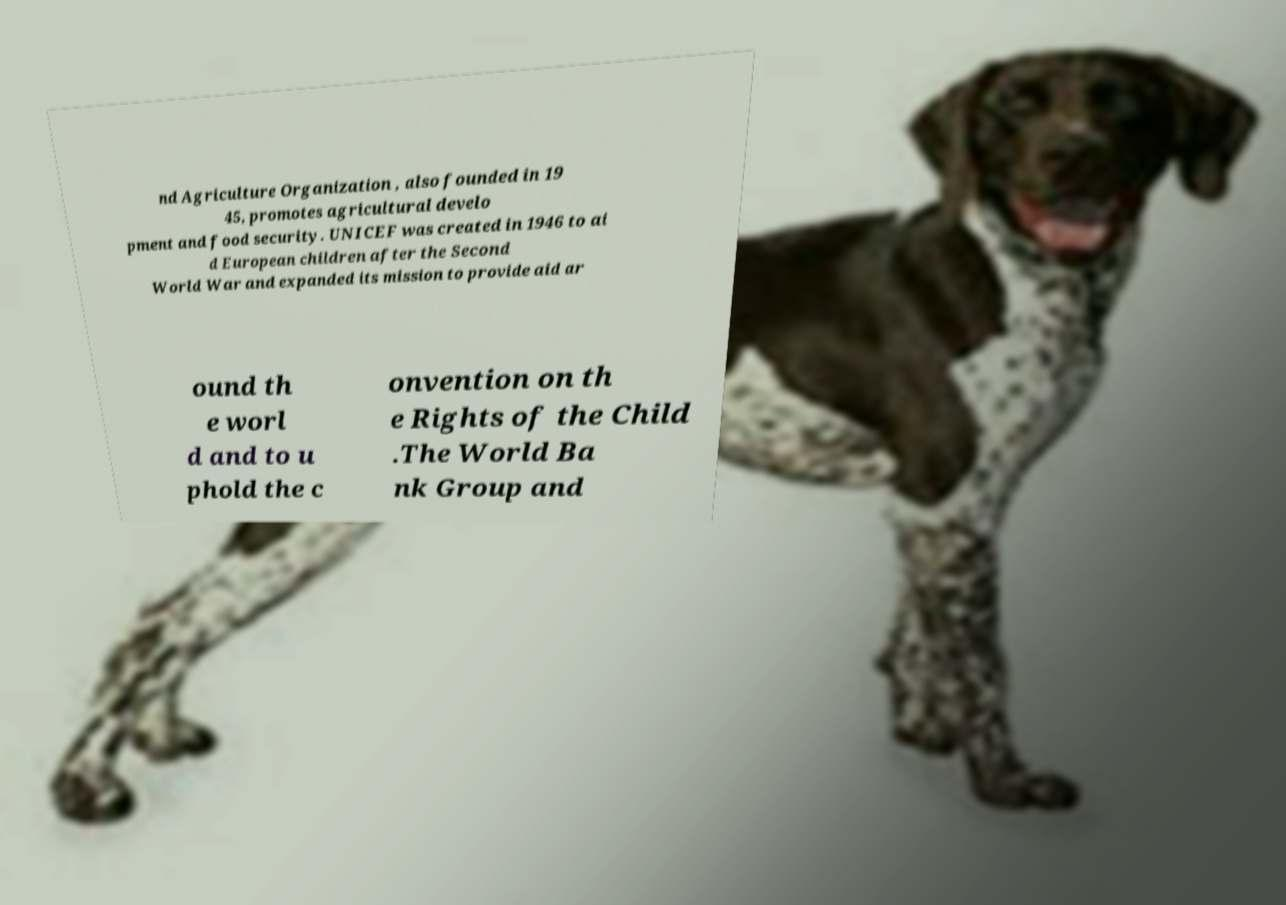Could you extract and type out the text from this image? nd Agriculture Organization , also founded in 19 45, promotes agricultural develo pment and food security. UNICEF was created in 1946 to ai d European children after the Second World War and expanded its mission to provide aid ar ound th e worl d and to u phold the c onvention on th e Rights of the Child .The World Ba nk Group and 